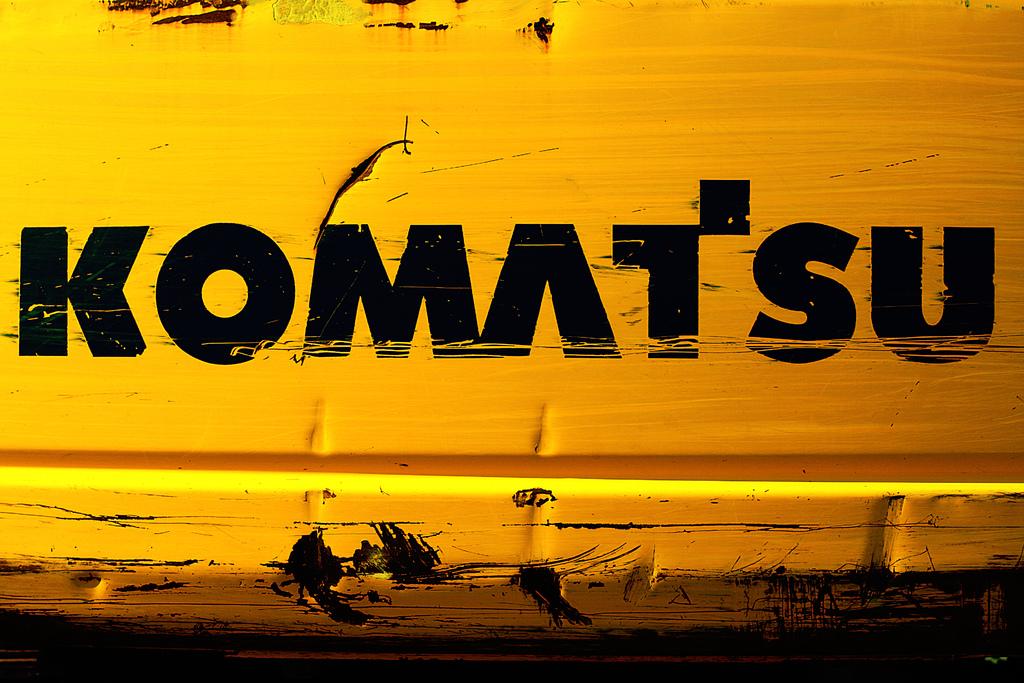What does it say?
Provide a succinct answer. Komatsu. 